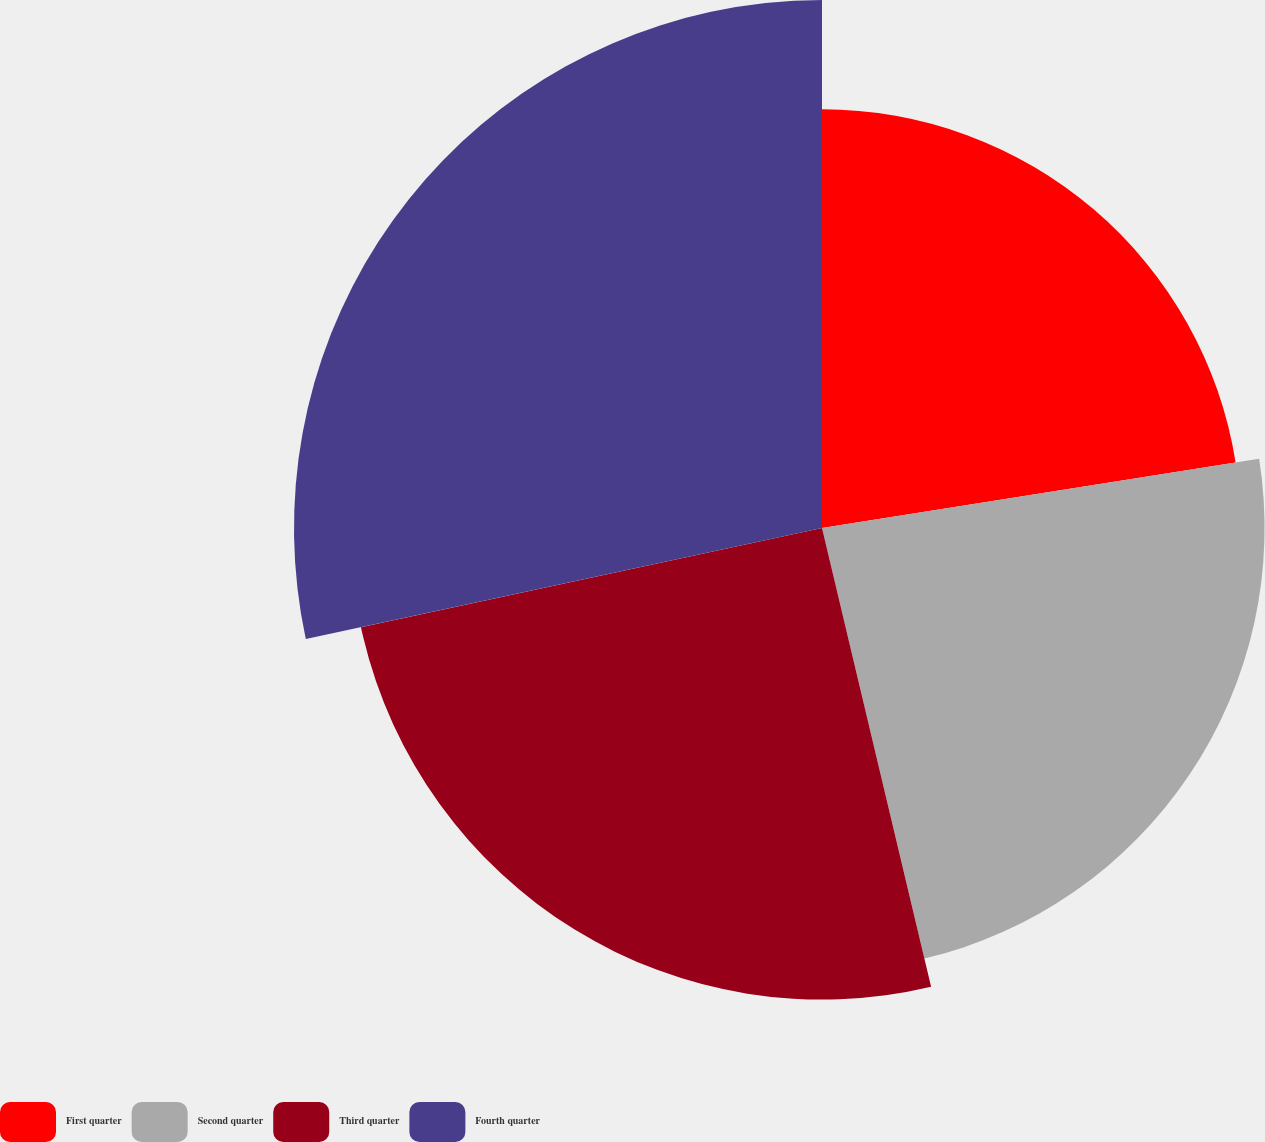Convert chart to OTSL. <chart><loc_0><loc_0><loc_500><loc_500><pie_chart><fcel>First quarter<fcel>Second quarter<fcel>Third quarter<fcel>Fourth quarter<nl><fcel>22.5%<fcel>23.78%<fcel>25.34%<fcel>28.37%<nl></chart> 